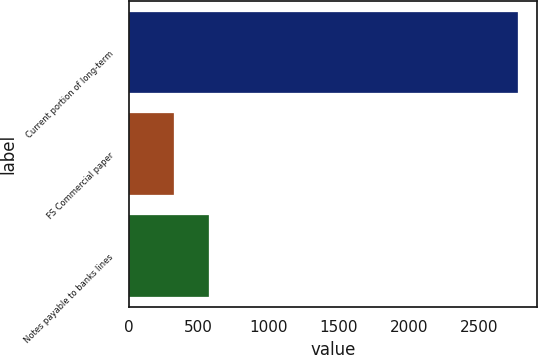Convert chart. <chart><loc_0><loc_0><loc_500><loc_500><bar_chart><fcel>Current portion of long-term<fcel>FS Commercial paper<fcel>Notes payable to banks lines<nl><fcel>2776<fcel>326<fcel>571<nl></chart> 